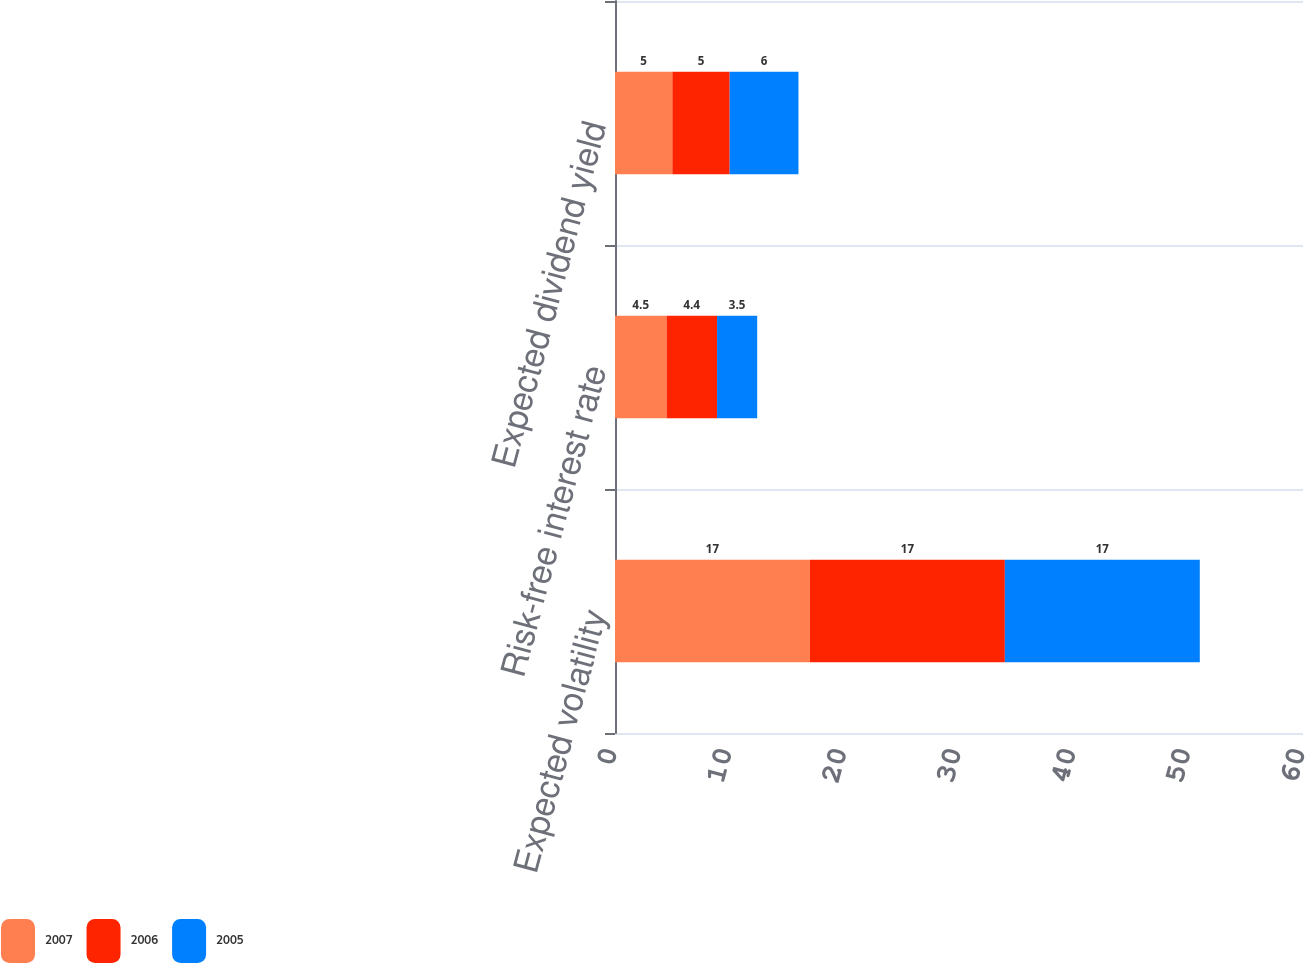Convert chart. <chart><loc_0><loc_0><loc_500><loc_500><stacked_bar_chart><ecel><fcel>Expected volatility<fcel>Risk-free interest rate<fcel>Expected dividend yield<nl><fcel>2007<fcel>17<fcel>4.5<fcel>5<nl><fcel>2006<fcel>17<fcel>4.4<fcel>5<nl><fcel>2005<fcel>17<fcel>3.5<fcel>6<nl></chart> 